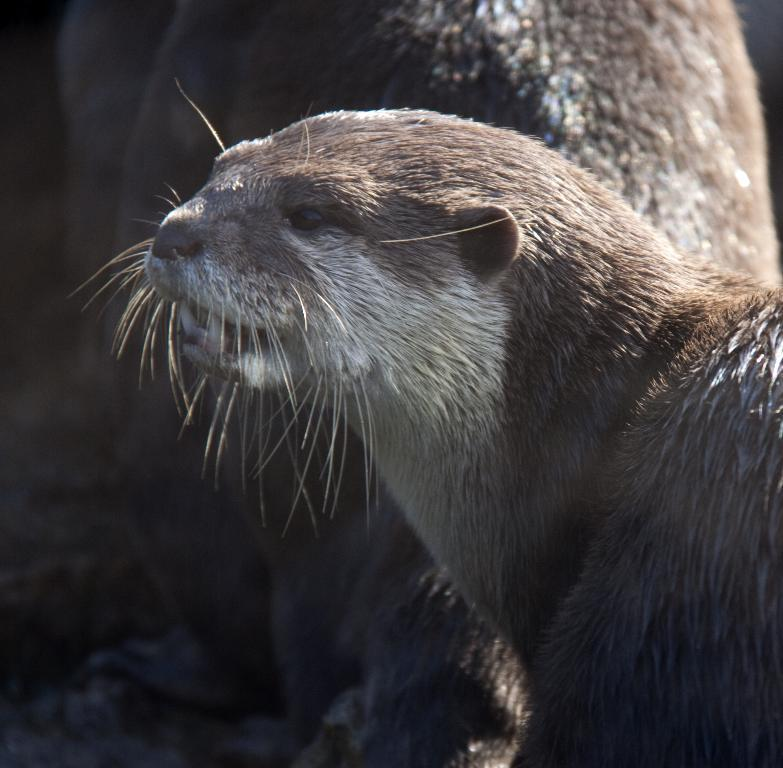What types of living organisms can be seen in the image? There are animals in the image. What is the surface on which the animals are situated? The ground is visible in the image. What type of drain can be seen in the image? There is no drain present in the image. How much salt is visible in the image? There is no salt present in the image. 